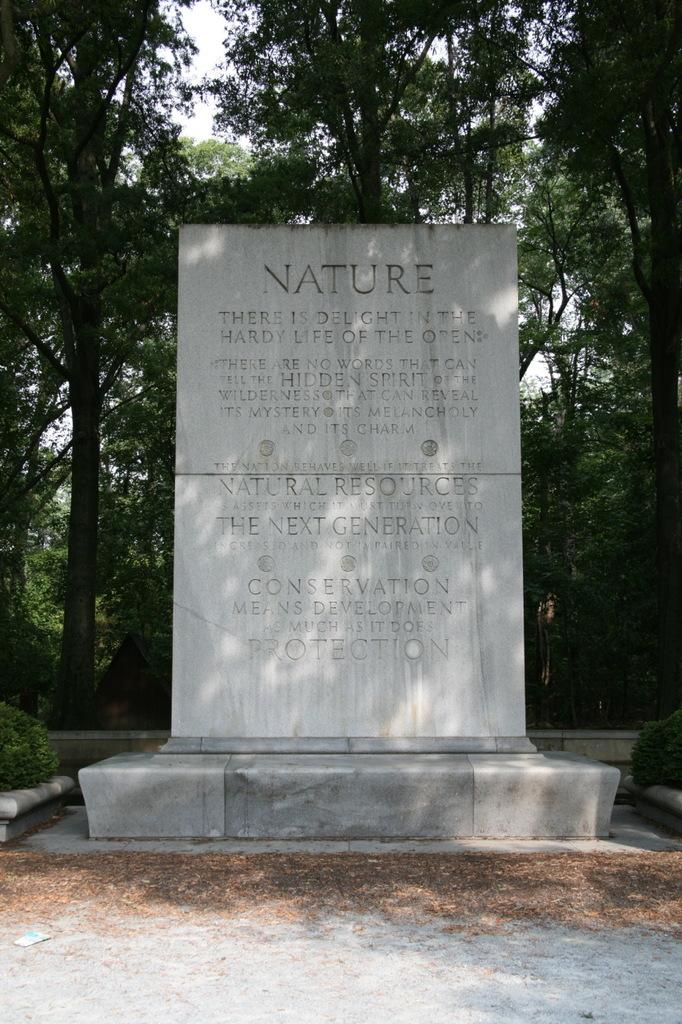What is the largest object in the image? There is a big rock in the image. Is there any writing or message on the rock? Yes, there is a note on the rock. What type of natural environment is depicted in the image? There are many trees visible in the image, suggesting a forest or wooded area. What is the name of the ray swimming near the rock in the image? There is no ray present in the image; it features a big rock with a note and many trees in the background. 